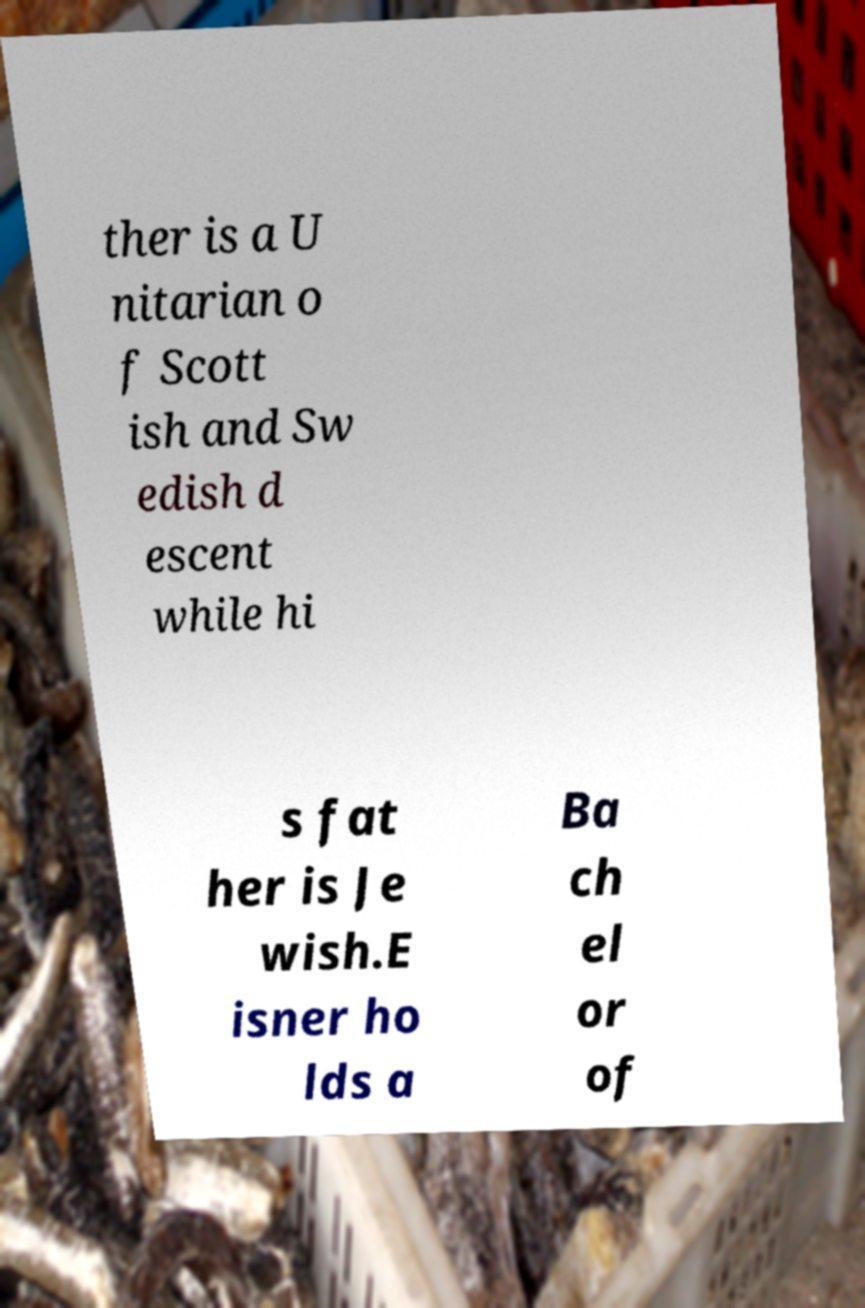For documentation purposes, I need the text within this image transcribed. Could you provide that? ther is a U nitarian o f Scott ish and Sw edish d escent while hi s fat her is Je wish.E isner ho lds a Ba ch el or of 